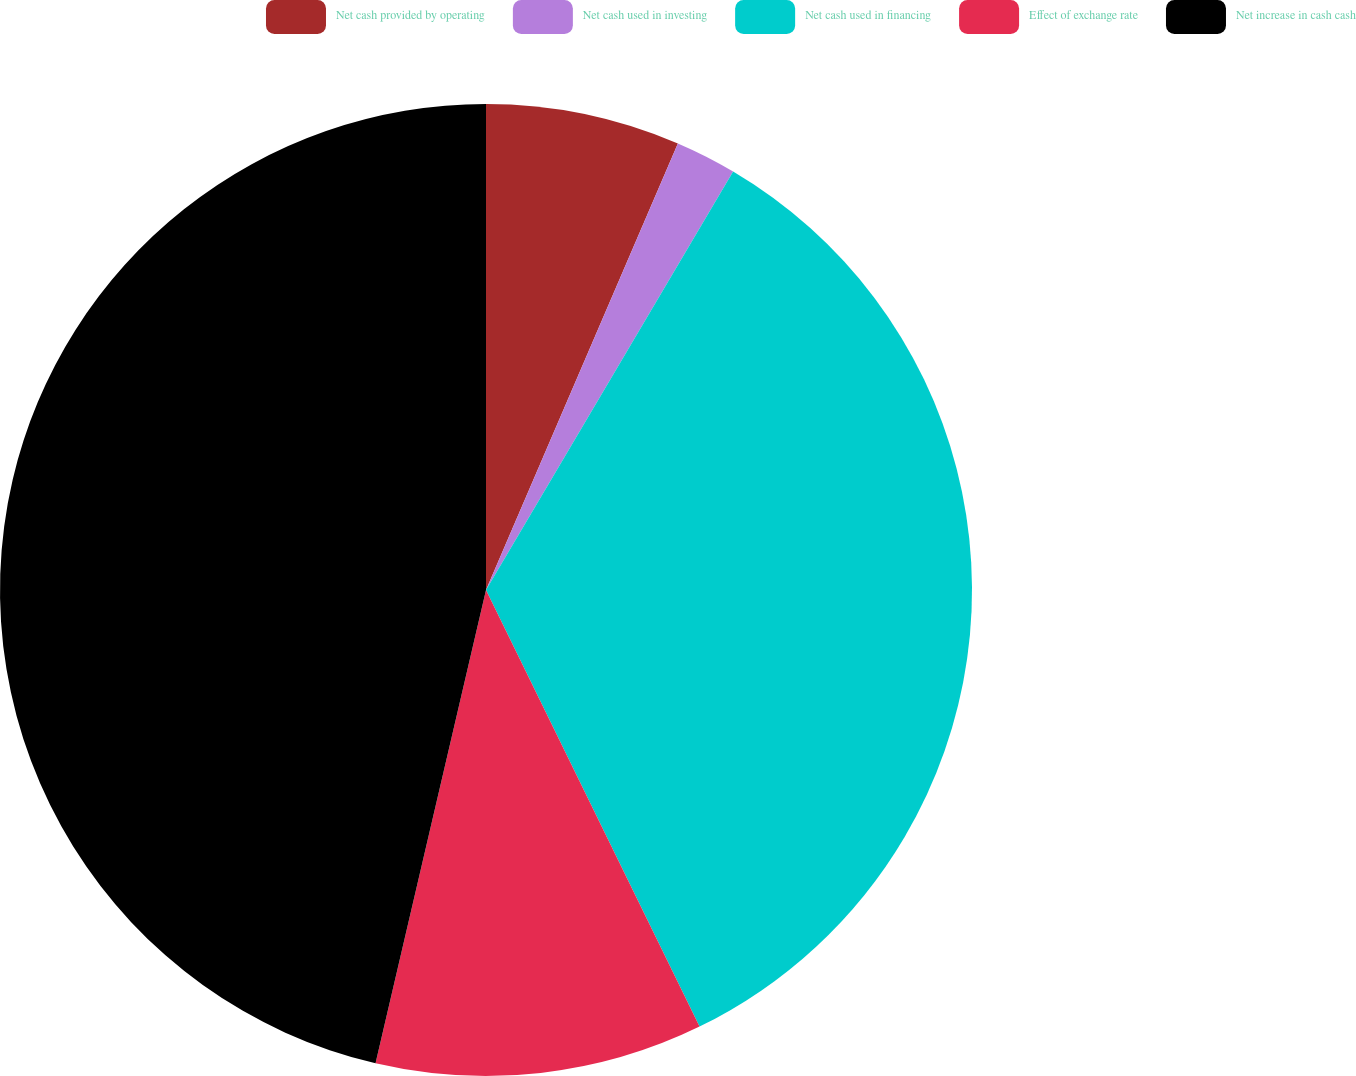Convert chart to OTSL. <chart><loc_0><loc_0><loc_500><loc_500><pie_chart><fcel>Net cash provided by operating<fcel>Net cash used in investing<fcel>Net cash used in financing<fcel>Effect of exchange rate<fcel>Net increase in cash cash<nl><fcel>6.46%<fcel>2.03%<fcel>34.27%<fcel>10.89%<fcel>46.35%<nl></chart> 